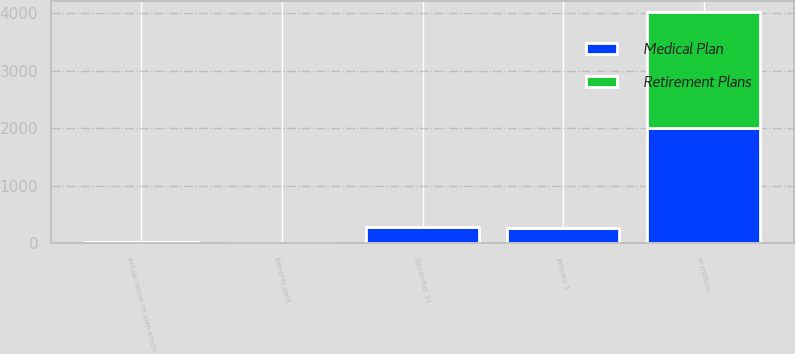Convert chart to OTSL. <chart><loc_0><loc_0><loc_500><loc_500><stacked_bar_chart><ecel><fcel>in millions<fcel>January 1<fcel>Actual return on plan assets<fcel>Benefits paid<fcel>December 31<nl><fcel>Medical Plan<fcel>2010<fcel>262.9<fcel>33.2<fcel>9.2<fcel>286<nl><fcel>Retirement Plans<fcel>2010<fcel>7.3<fcel>0.8<fcel>0.2<fcel>8.1<nl></chart> 